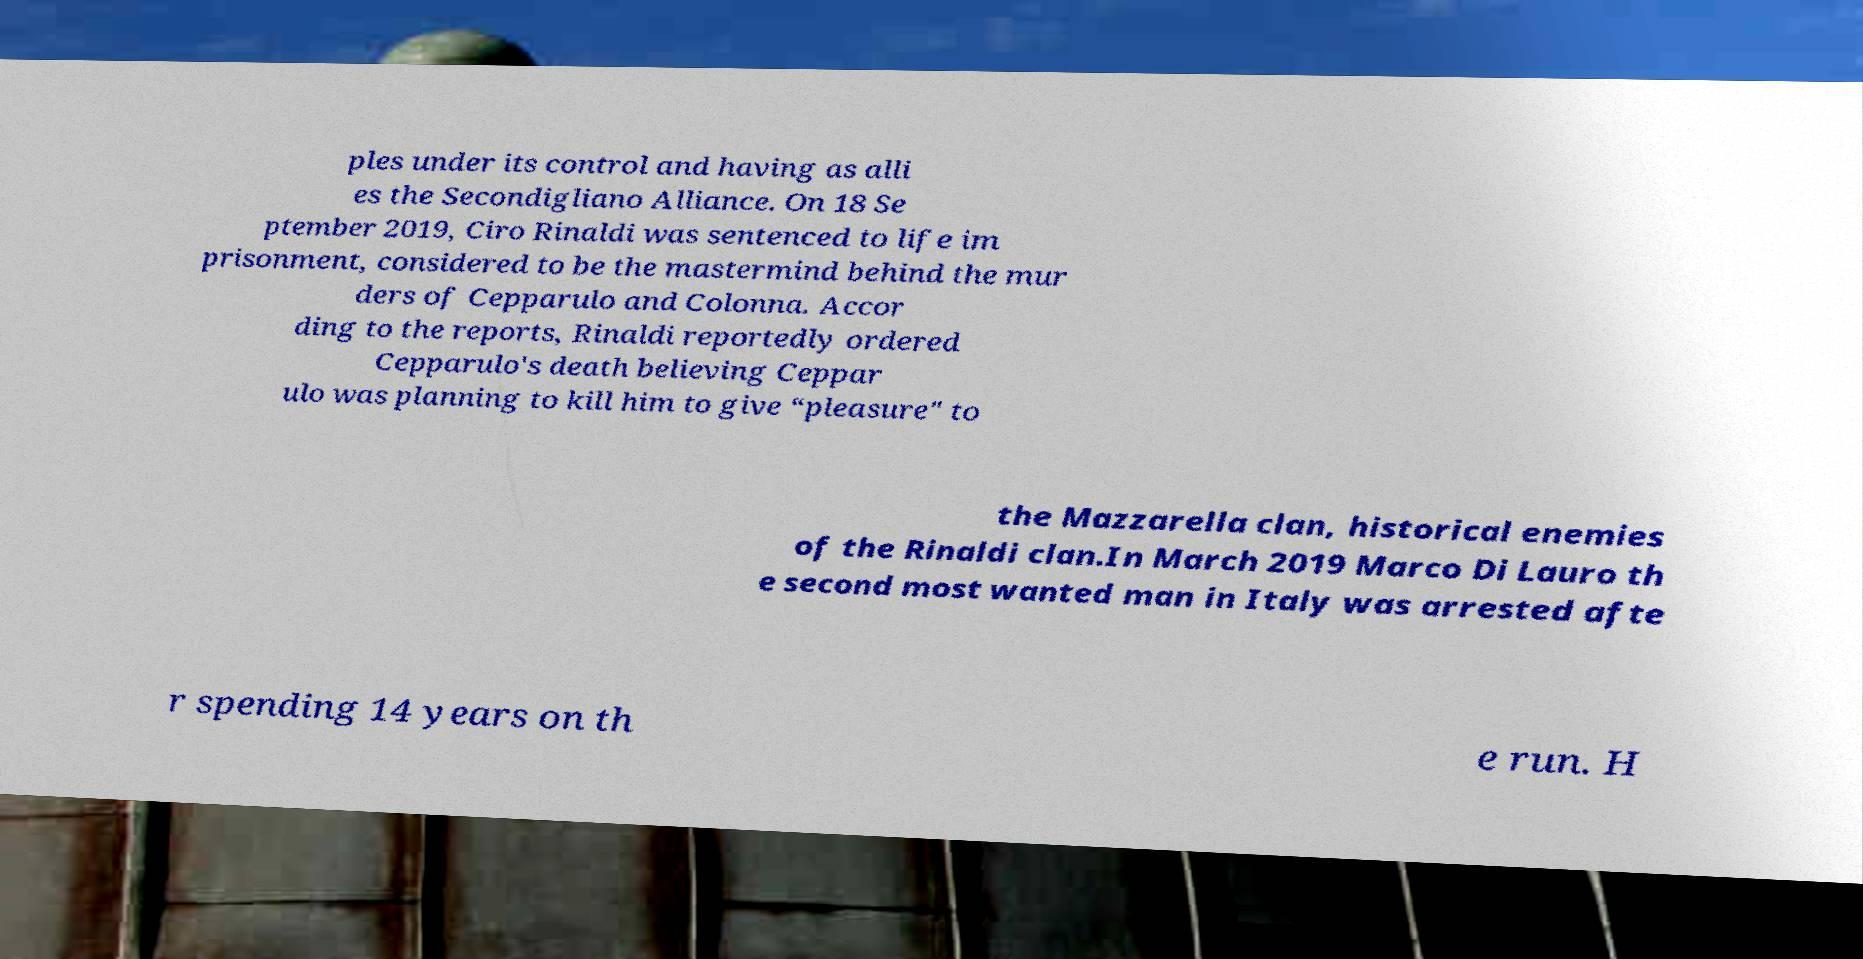I need the written content from this picture converted into text. Can you do that? ples under its control and having as alli es the Secondigliano Alliance. On 18 Se ptember 2019, Ciro Rinaldi was sentenced to life im prisonment, considered to be the mastermind behind the mur ders of Cepparulo and Colonna. Accor ding to the reports, Rinaldi reportedly ordered Cepparulo's death believing Ceppar ulo was planning to kill him to give “pleasure" to the Mazzarella clan, historical enemies of the Rinaldi clan.In March 2019 Marco Di Lauro th e second most wanted man in Italy was arrested afte r spending 14 years on th e run. H 